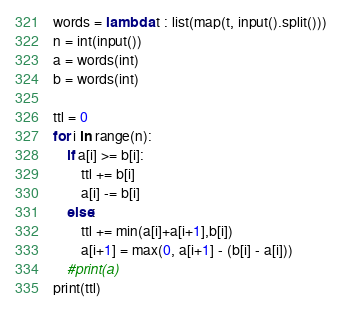<code> <loc_0><loc_0><loc_500><loc_500><_Python_>words = lambda t : list(map(t, input().split()))
n = int(input())
a = words(int)
b = words(int)

ttl = 0
for i in range(n):
    if a[i] >= b[i]:
        ttl += b[i]
        a[i] -= b[i]
    else:
        ttl += min(a[i]+a[i+1],b[i])
        a[i+1] = max(0, a[i+1] - (b[i] - a[i]))
    #print(a)
print(ttl)
</code> 